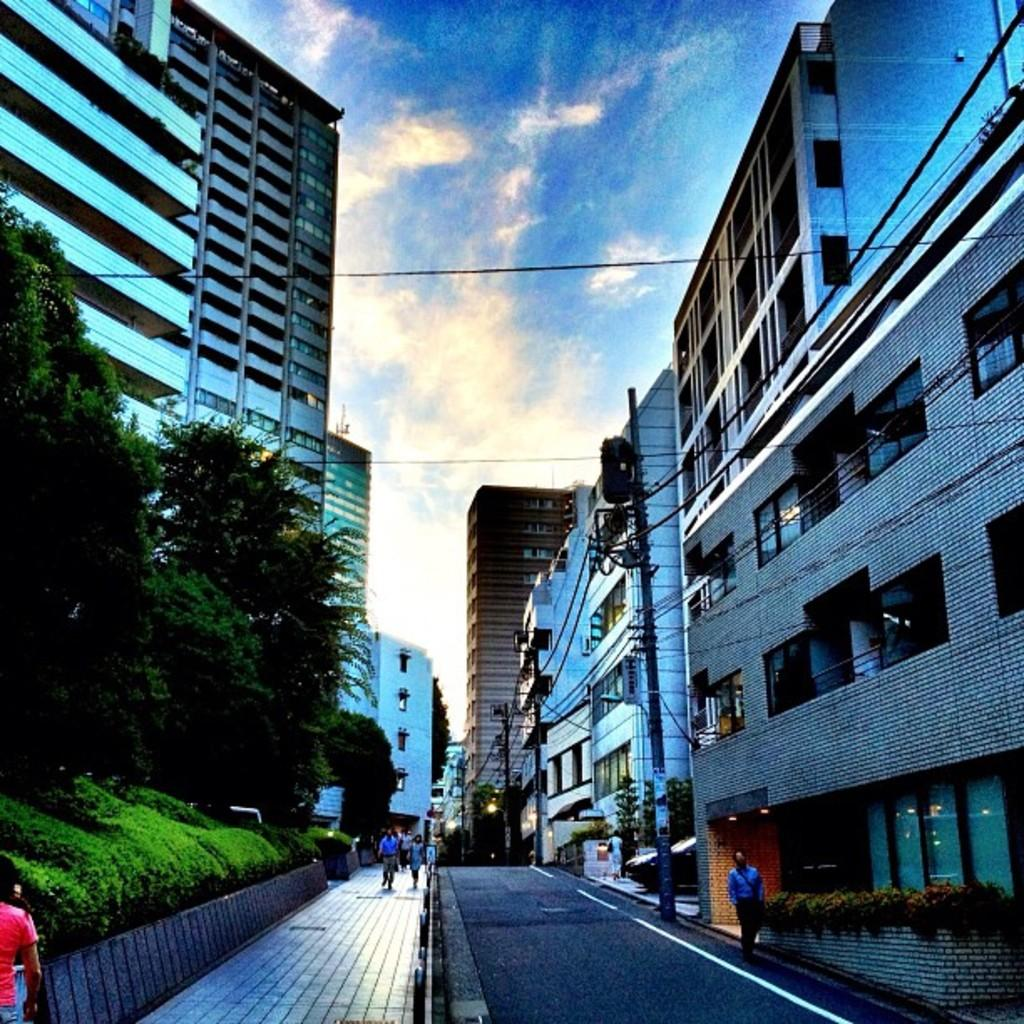What type of structures can be seen in the image? There are buildings in the image. What else can be seen in the image besides buildings? There are poles, wires, trees, and plants visible in the image. What is at the bottom of the image? There is a road and a footpath at the bottom of the image. What are people doing in the image? People are walking in the image. What is visible at the top of the image? The sky is visible at the top of the image. Can you tell me the plot of the story being told by the receipt in the image? There is no receipt present in the image, so there is no story to tell. What is the height of the low-hanging clouds in the image? There are no clouds visible in the image, so it is not possible to determine the height of any low-hanging clouds. 